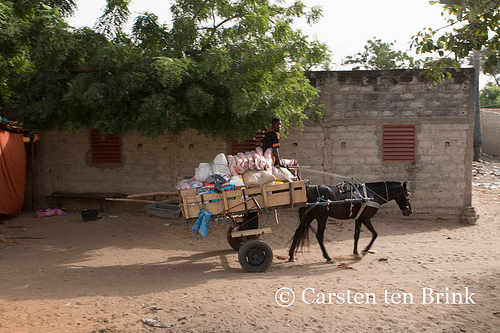<image>
Can you confirm if the sky is behind the house? Yes. From this viewpoint, the sky is positioned behind the house, with the house partially or fully occluding the sky. 